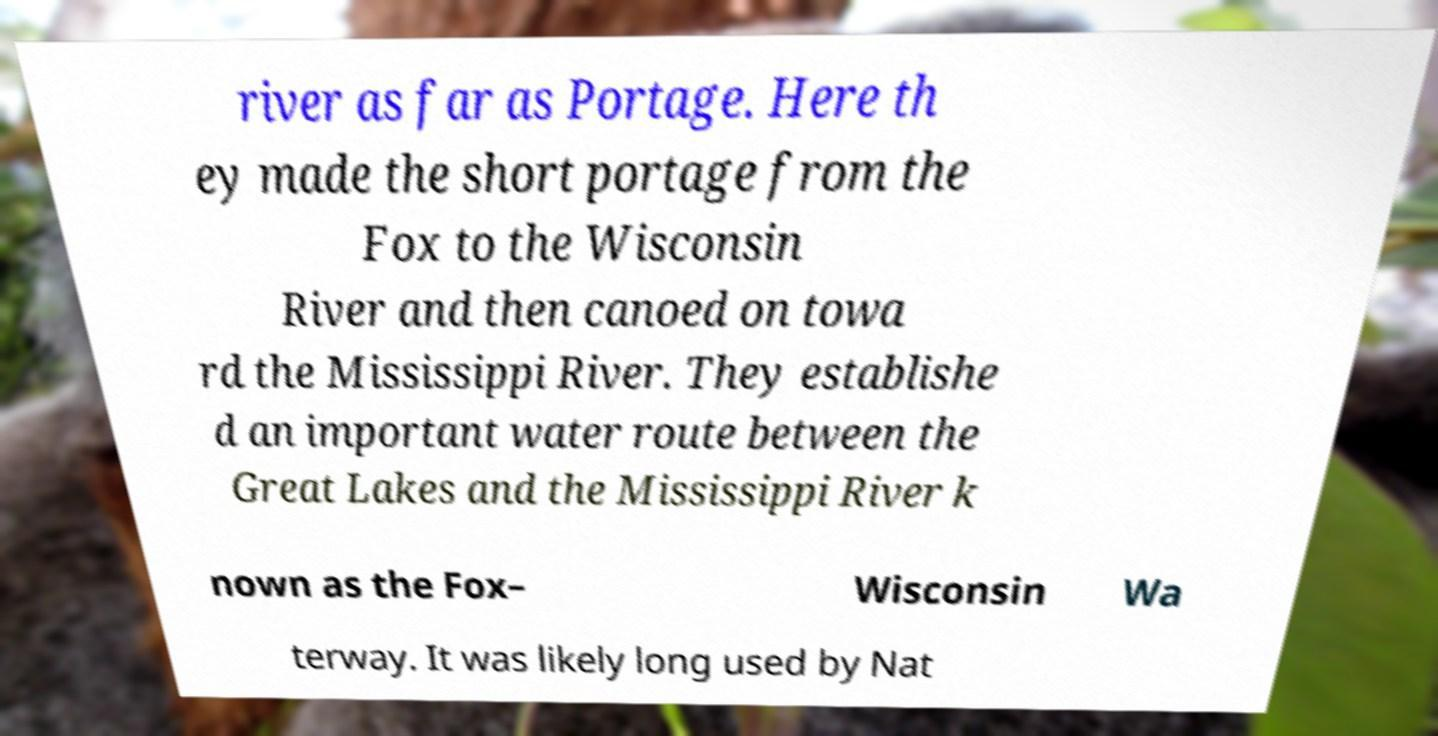There's text embedded in this image that I need extracted. Can you transcribe it verbatim? river as far as Portage. Here th ey made the short portage from the Fox to the Wisconsin River and then canoed on towa rd the Mississippi River. They establishe d an important water route between the Great Lakes and the Mississippi River k nown as the Fox– Wisconsin Wa terway. It was likely long used by Nat 